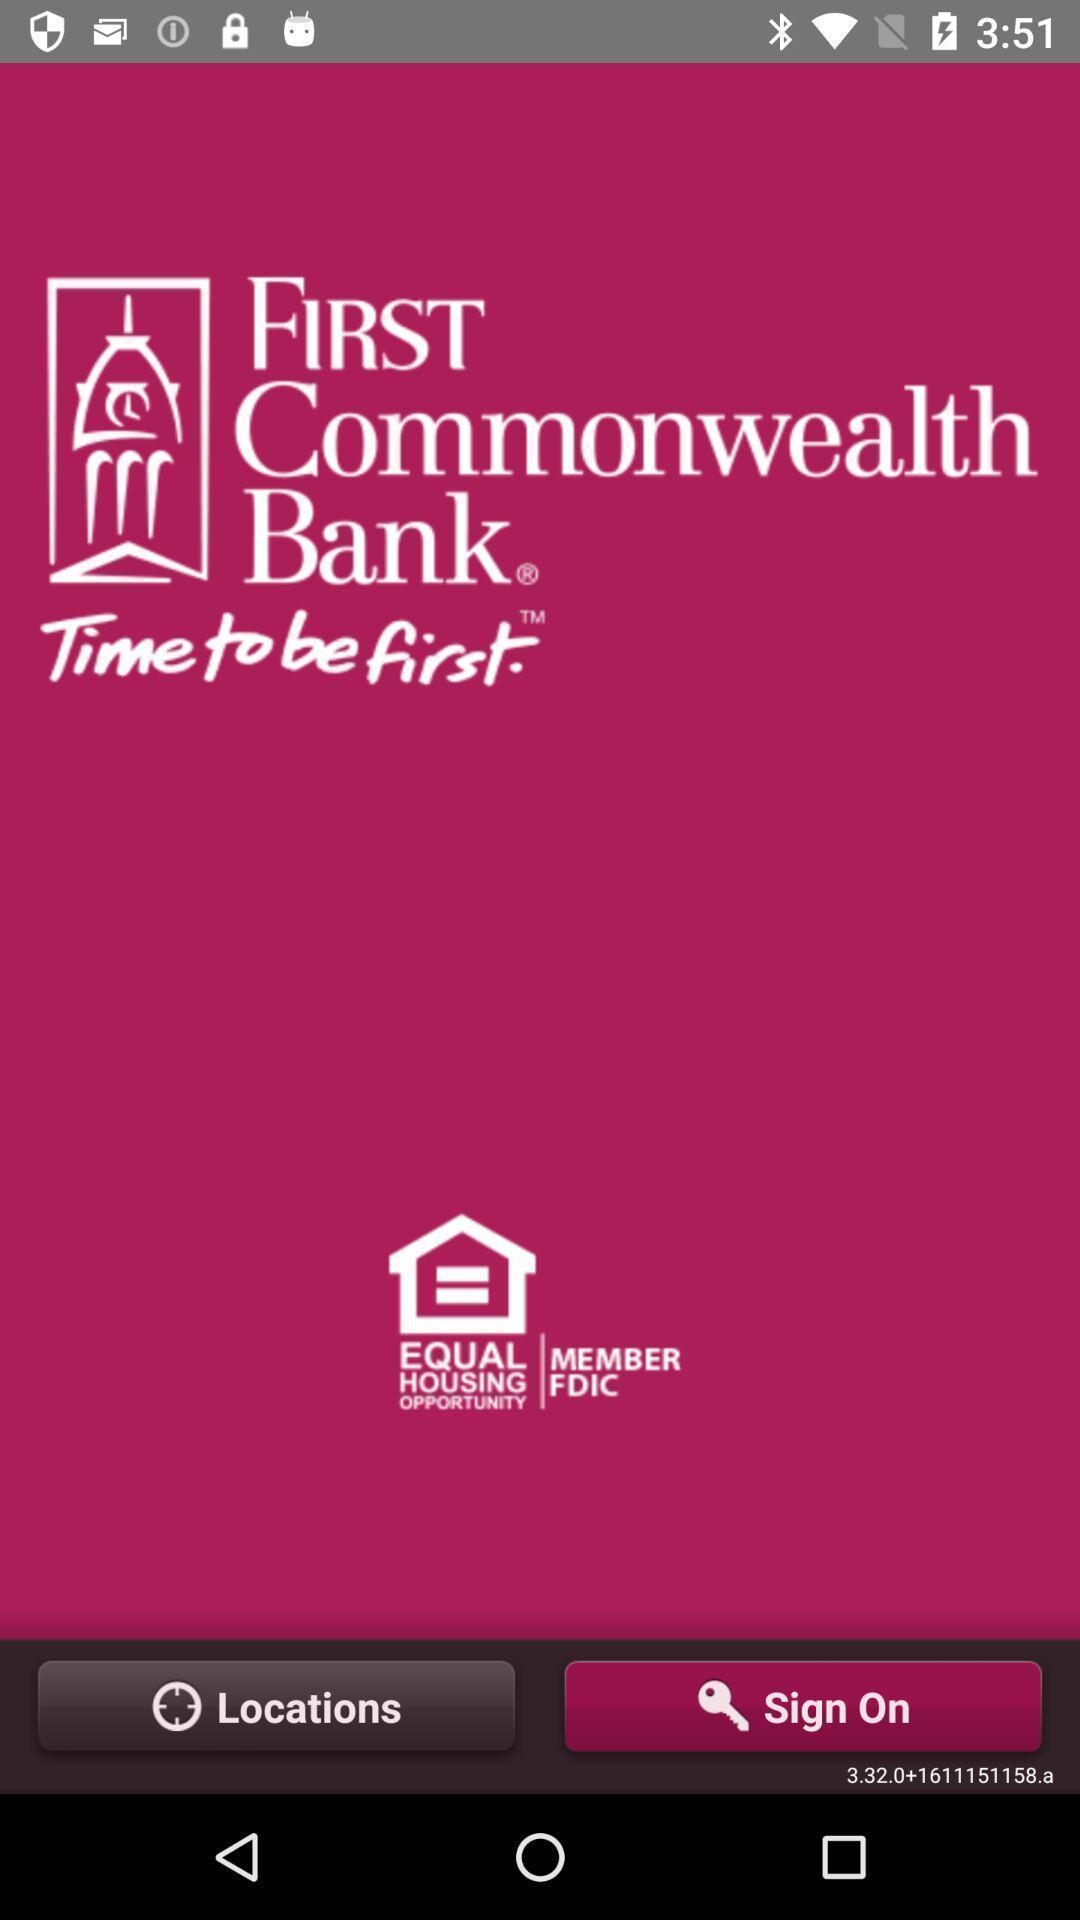Describe the visual elements of this screenshot. Welcome page of the bank app. 